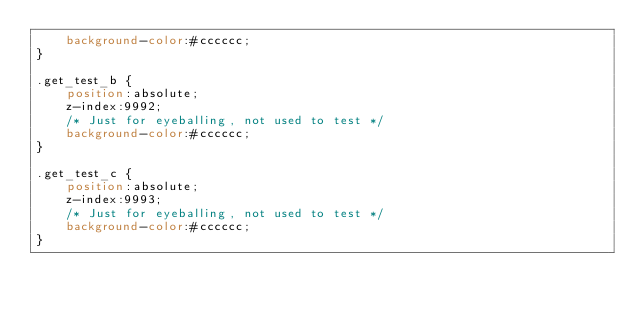Convert code to text. <code><loc_0><loc_0><loc_500><loc_500><_CSS_>    background-color:#cccccc;
}

.get_test_b {
    position:absolute;
    z-index:9992;
    /* Just for eyeballing, not used to test */    
    background-color:#cccccc;
}

.get_test_c {
    position:absolute;
    z-index:9993;
    /* Just for eyeballing, not used to test */    
    background-color:#cccccc;
}</code> 